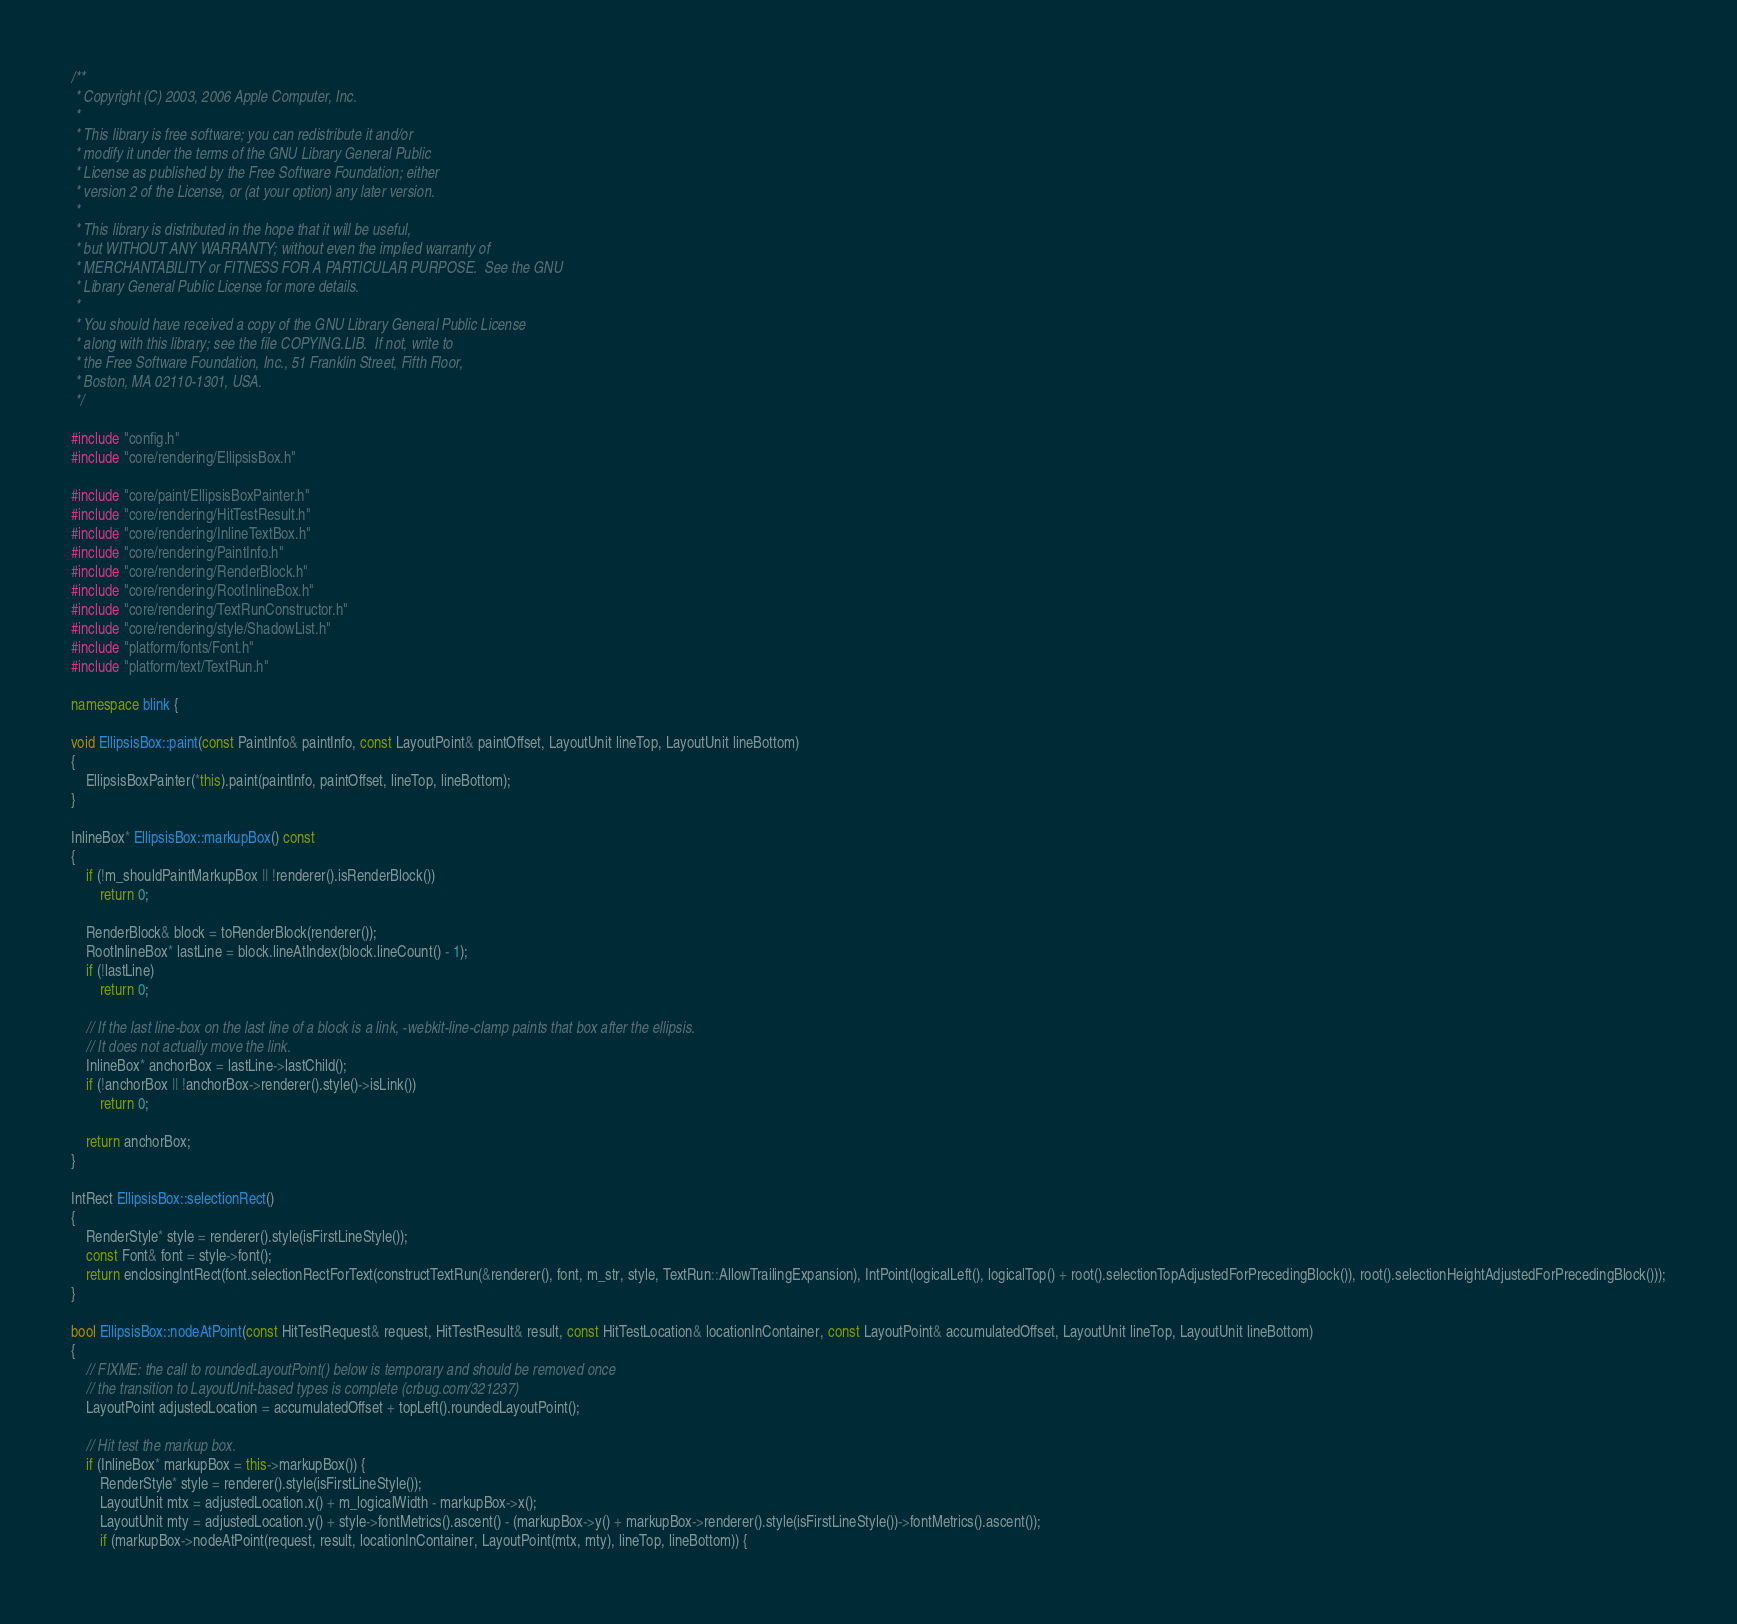<code> <loc_0><loc_0><loc_500><loc_500><_C++_>/**
 * Copyright (C) 2003, 2006 Apple Computer, Inc.
 *
 * This library is free software; you can redistribute it and/or
 * modify it under the terms of the GNU Library General Public
 * License as published by the Free Software Foundation; either
 * version 2 of the License, or (at your option) any later version.
 *
 * This library is distributed in the hope that it will be useful,
 * but WITHOUT ANY WARRANTY; without even the implied warranty of
 * MERCHANTABILITY or FITNESS FOR A PARTICULAR PURPOSE.  See the GNU
 * Library General Public License for more details.
 *
 * You should have received a copy of the GNU Library General Public License
 * along with this library; see the file COPYING.LIB.  If not, write to
 * the Free Software Foundation, Inc., 51 Franklin Street, Fifth Floor,
 * Boston, MA 02110-1301, USA.
 */

#include "config.h"
#include "core/rendering/EllipsisBox.h"

#include "core/paint/EllipsisBoxPainter.h"
#include "core/rendering/HitTestResult.h"
#include "core/rendering/InlineTextBox.h"
#include "core/rendering/PaintInfo.h"
#include "core/rendering/RenderBlock.h"
#include "core/rendering/RootInlineBox.h"
#include "core/rendering/TextRunConstructor.h"
#include "core/rendering/style/ShadowList.h"
#include "platform/fonts/Font.h"
#include "platform/text/TextRun.h"

namespace blink {

void EllipsisBox::paint(const PaintInfo& paintInfo, const LayoutPoint& paintOffset, LayoutUnit lineTop, LayoutUnit lineBottom)
{
    EllipsisBoxPainter(*this).paint(paintInfo, paintOffset, lineTop, lineBottom);
}

InlineBox* EllipsisBox::markupBox() const
{
    if (!m_shouldPaintMarkupBox || !renderer().isRenderBlock())
        return 0;

    RenderBlock& block = toRenderBlock(renderer());
    RootInlineBox* lastLine = block.lineAtIndex(block.lineCount() - 1);
    if (!lastLine)
        return 0;

    // If the last line-box on the last line of a block is a link, -webkit-line-clamp paints that box after the ellipsis.
    // It does not actually move the link.
    InlineBox* anchorBox = lastLine->lastChild();
    if (!anchorBox || !anchorBox->renderer().style()->isLink())
        return 0;

    return anchorBox;
}

IntRect EllipsisBox::selectionRect()
{
    RenderStyle* style = renderer().style(isFirstLineStyle());
    const Font& font = style->font();
    return enclosingIntRect(font.selectionRectForText(constructTextRun(&renderer(), font, m_str, style, TextRun::AllowTrailingExpansion), IntPoint(logicalLeft(), logicalTop() + root().selectionTopAdjustedForPrecedingBlock()), root().selectionHeightAdjustedForPrecedingBlock()));
}

bool EllipsisBox::nodeAtPoint(const HitTestRequest& request, HitTestResult& result, const HitTestLocation& locationInContainer, const LayoutPoint& accumulatedOffset, LayoutUnit lineTop, LayoutUnit lineBottom)
{
    // FIXME: the call to roundedLayoutPoint() below is temporary and should be removed once
    // the transition to LayoutUnit-based types is complete (crbug.com/321237)
    LayoutPoint adjustedLocation = accumulatedOffset + topLeft().roundedLayoutPoint();

    // Hit test the markup box.
    if (InlineBox* markupBox = this->markupBox()) {
        RenderStyle* style = renderer().style(isFirstLineStyle());
        LayoutUnit mtx = adjustedLocation.x() + m_logicalWidth - markupBox->x();
        LayoutUnit mty = adjustedLocation.y() + style->fontMetrics().ascent() - (markupBox->y() + markupBox->renderer().style(isFirstLineStyle())->fontMetrics().ascent());
        if (markupBox->nodeAtPoint(request, result, locationInContainer, LayoutPoint(mtx, mty), lineTop, lineBottom)) {</code> 